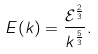Convert formula to latex. <formula><loc_0><loc_0><loc_500><loc_500>E ( k ) = \frac { \mathcal { E } ^ { \frac { 2 } { 3 } } } { k ^ { \frac { 5 } { 3 } } } .</formula> 